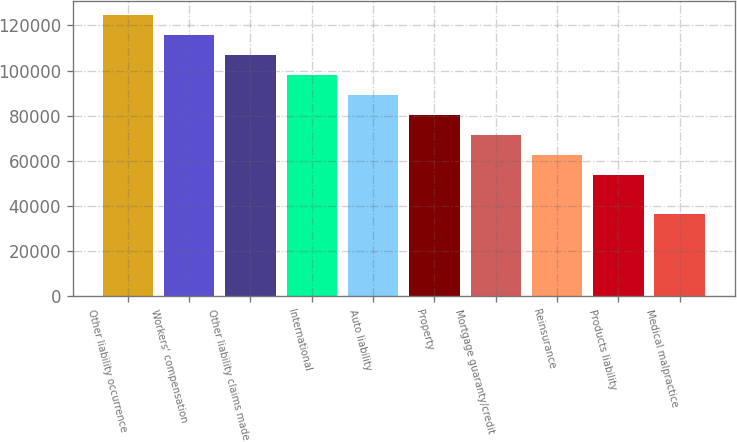<chart> <loc_0><loc_0><loc_500><loc_500><bar_chart><fcel>Other liability occurrence<fcel>Workers' compensation<fcel>Other liability claims made<fcel>International<fcel>Auto liability<fcel>Property<fcel>Mortgage guaranty/credit<fcel>Reinsurance<fcel>Products liability<fcel>Medical malpractice<nl><fcel>124550<fcel>115727<fcel>106904<fcel>98081<fcel>89258<fcel>80435<fcel>71612<fcel>62789<fcel>53966<fcel>36320<nl></chart> 